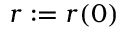Convert formula to latex. <formula><loc_0><loc_0><loc_500><loc_500>r \colon = r ( 0 )</formula> 